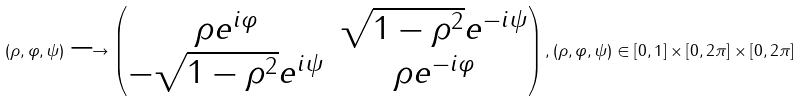<formula> <loc_0><loc_0><loc_500><loc_500>( \rho , \varphi , \psi ) \longrightarrow \begin{pmatrix} \rho e ^ { i \varphi } & \sqrt { 1 - \rho ^ { 2 } } e ^ { - i \psi } \\ - \sqrt { 1 - \rho ^ { 2 } } e ^ { i \psi } & \rho e ^ { - i \varphi } \end{pmatrix} , ( \rho , \varphi , \psi ) \in [ 0 , 1 ] \times [ 0 , 2 \pi ] \times [ 0 , 2 \pi ]</formula> 